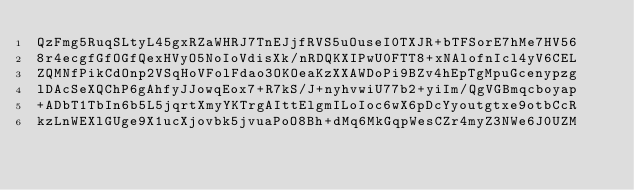<code> <loc_0><loc_0><loc_500><loc_500><_SML_>QzFmg5RuqSLtyL45gxRZaWHRJ7TnEJjfRVS5uOuseI0TXJR+bTFSorE7hMe7HV56
8r4ecgfGfOGfQexHVyO5NoIoVdisXk/nRDQKXIPwU0FTT8+xNAlofnIcl4yV6CEL
ZQMNfPikCdOnp2VSqHoVFolFdao3OKOeaKzXXAWDoPi9BZv4hEpTgMpuGcenypzg
lDAcSeXQChP6gAhfyJJowqEox7+R7kS/J+nyhvwiU77b2+yiIm/QgVGBmqcboyap
+ADbT1TbIn6b5L5jqrtXmyYKTrgAIttElgmILoIoc6wX6pDcYyoutgtxe9otbCcR
kzLnWEXlGUge9X1ucXjovbk5jvuaPoO8Bh+dMq6MkGqpWesCZr4myZ3NWe6J0UZM</code> 